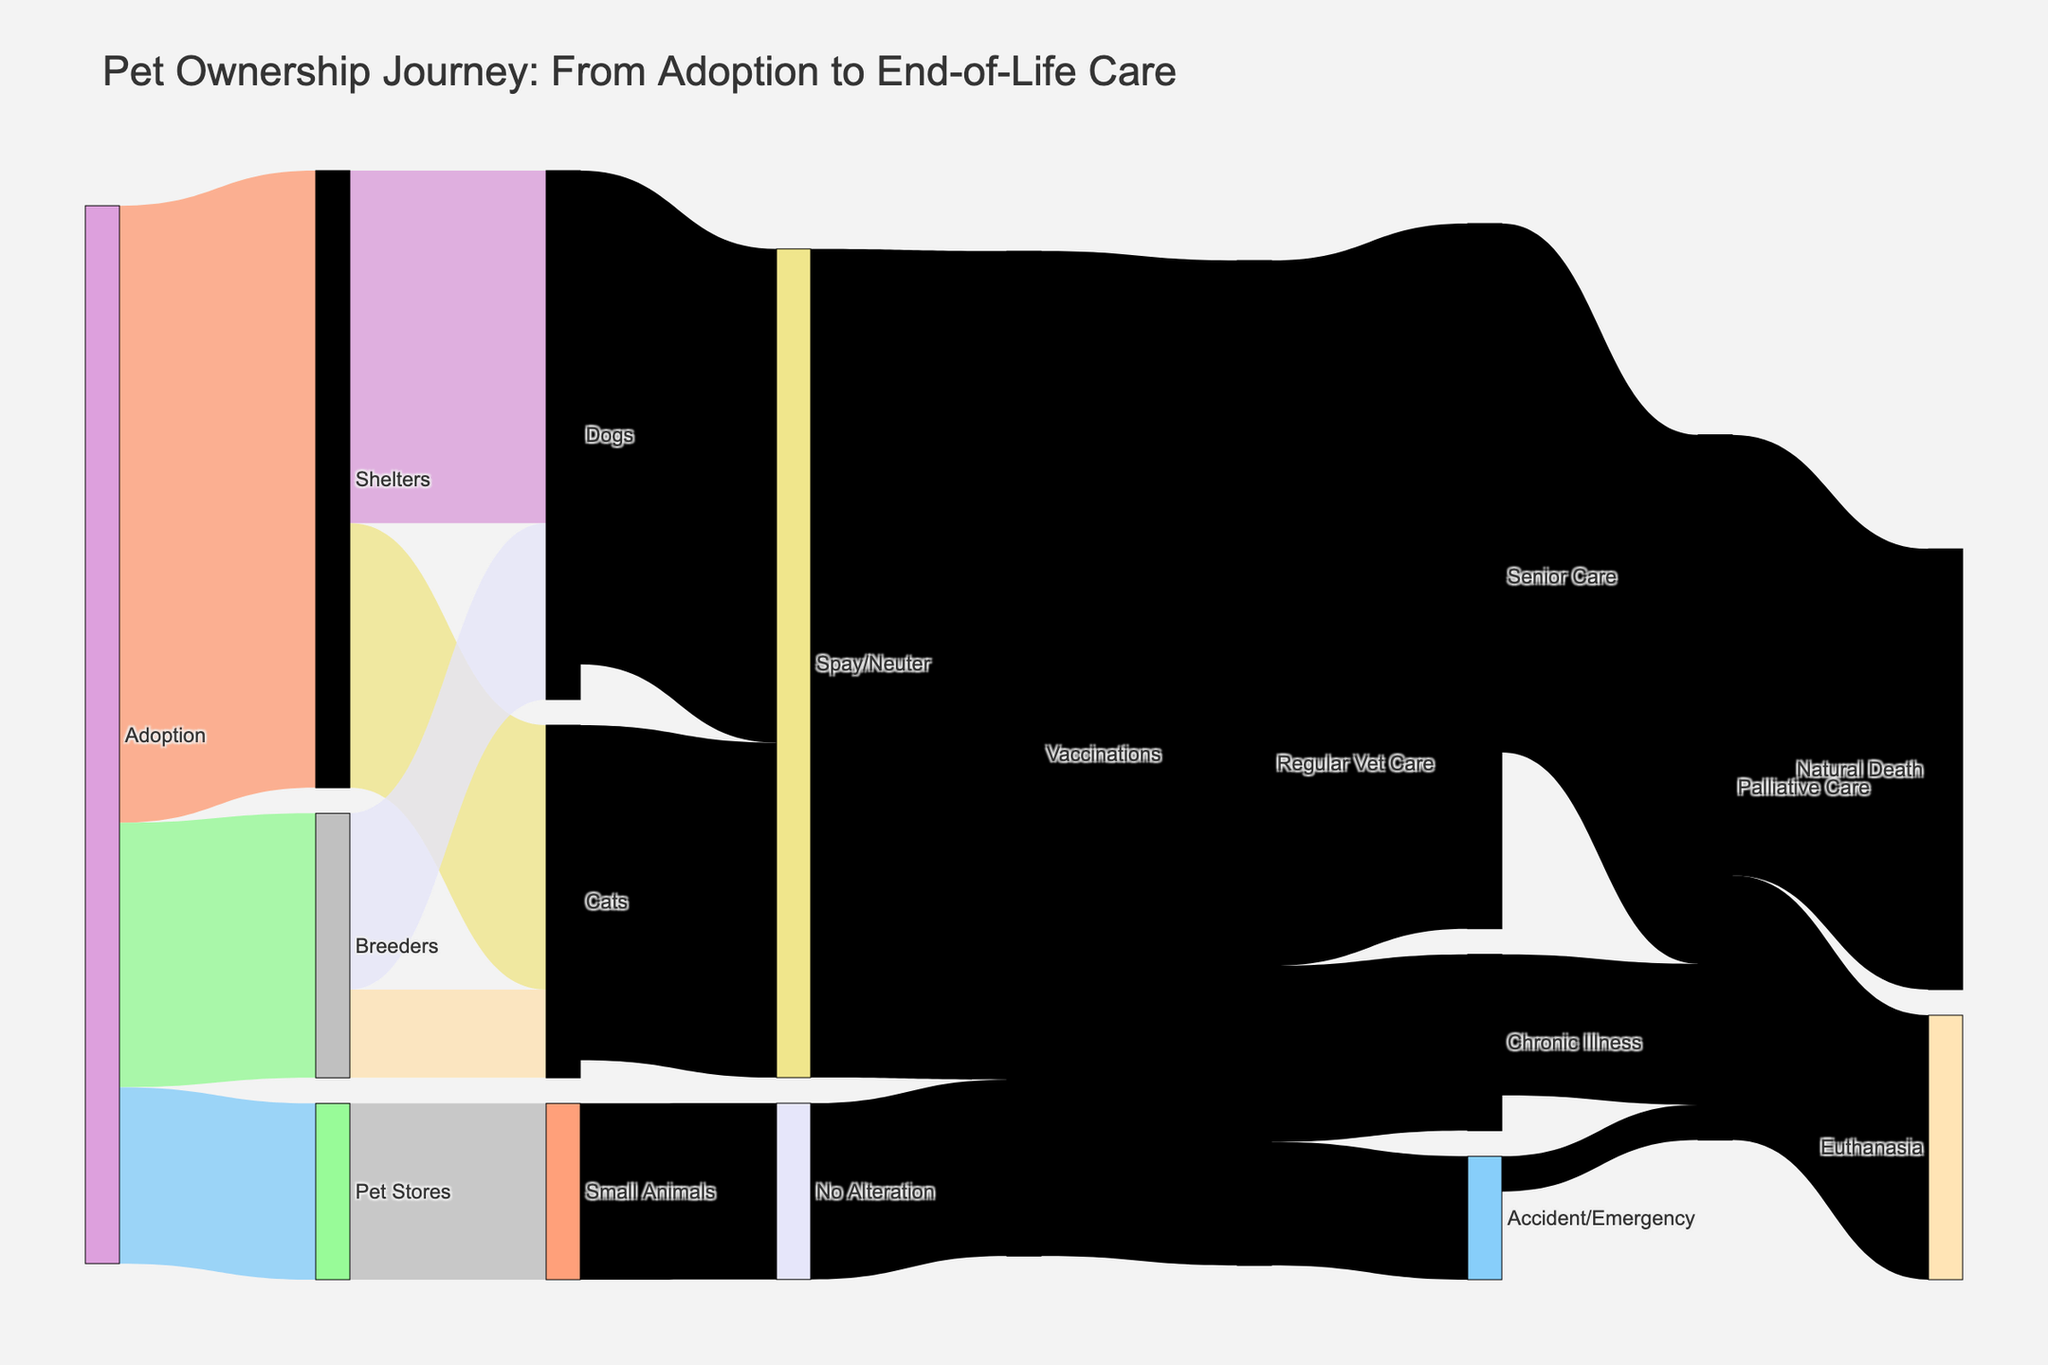what is the title of the Sankey diagram? Look at the top of the diagram to find the title text. It is designed to summarize the content of the visualization.
Answer: Pet Ownership Journey: From Adoption to End-of-Life Care How many pets are adopted from shelters? Identify the flow from "Adoption" to "Shelters" and note its value. This indicates the count of pets adopting from shelters.
Answer: 350 How many animals undergo spay/neuter after adoption? Sum the values for the transitions from "Dogs" to "Spay/Neuter" and "Cats" to "Spay/Neuter". This represents the total pets who undergo spay/neuter procedures after adoption.
Answer: 280 + 190 = 470 Which source contributes the most to pet ownership? Compare the values originating from "Adoption" and identify the highest one. This shows which source contributes the largest amount.
Answer: Adoption to Shelters with 350 Where do all the small animals come from? Locate the transition connected to "Small Animals" and find its source. This tells where the small animals are acquired.
Answer: Pet Stores What are the different routes to palliative care? Trace all the flows that lead up to "Palliative Care". Identify each different path and consolidating them will illustrate every route to palliative care.
Answer: From Senior Care, Chronic Illness, and Accident/Emergency How many pets receive vaccinations? Combine the flows leading to "Vaccinations" from both "Spay/Neuter" and "No Alteration". Sum these values to get the total number of pets vaccinated.
Answer: 470 + 100 = 570 How does the number of pets receiving regular vet care compare to those under spay/neuter? Compare the values of flows leading to "Regular Vet Care" and "Spay/Neuter". This will tell you which is higher and by how much.
Answer: Regular Vet Care is higher by 570 - 470 = 100 What happens to pets under senior care eventually? Trace the flows coming out from "Senior Care" to see the subsequent stages. Each target will specify what happens to these pets.
Answer: They go to Palliative Care What proportion of palliative care pets undergo euthanasia versus natural death? Compare the flow values moving from "Palliative Care" to "Euthanasia" and "Natural Death". Calculate the proportion between these two destinations.
Answer: Euthanasia: 150/400; Natural Death: 250/400 